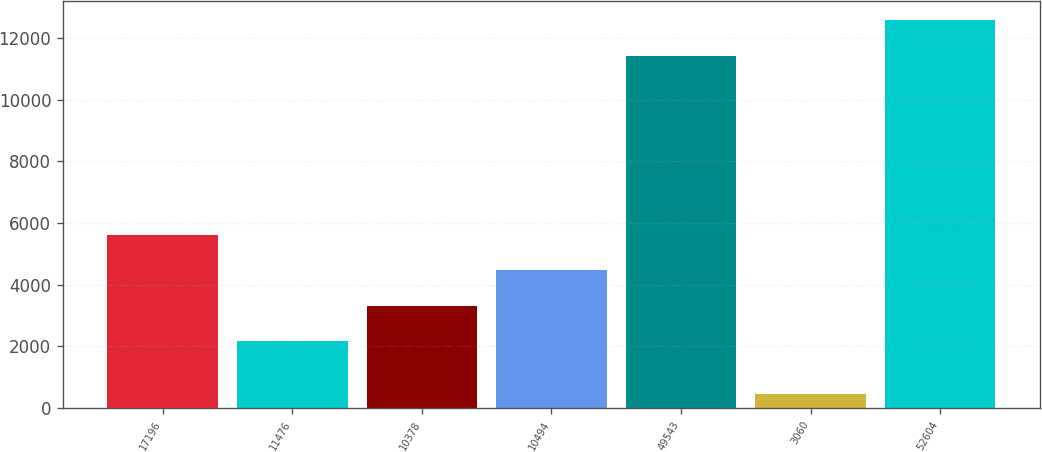<chart> <loc_0><loc_0><loc_500><loc_500><bar_chart><fcel>17196<fcel>11476<fcel>10378<fcel>10494<fcel>49543<fcel>3060<fcel>52604<nl><fcel>5601.09<fcel>2170.5<fcel>3314.03<fcel>4457.56<fcel>11435.3<fcel>449<fcel>12578.8<nl></chart> 